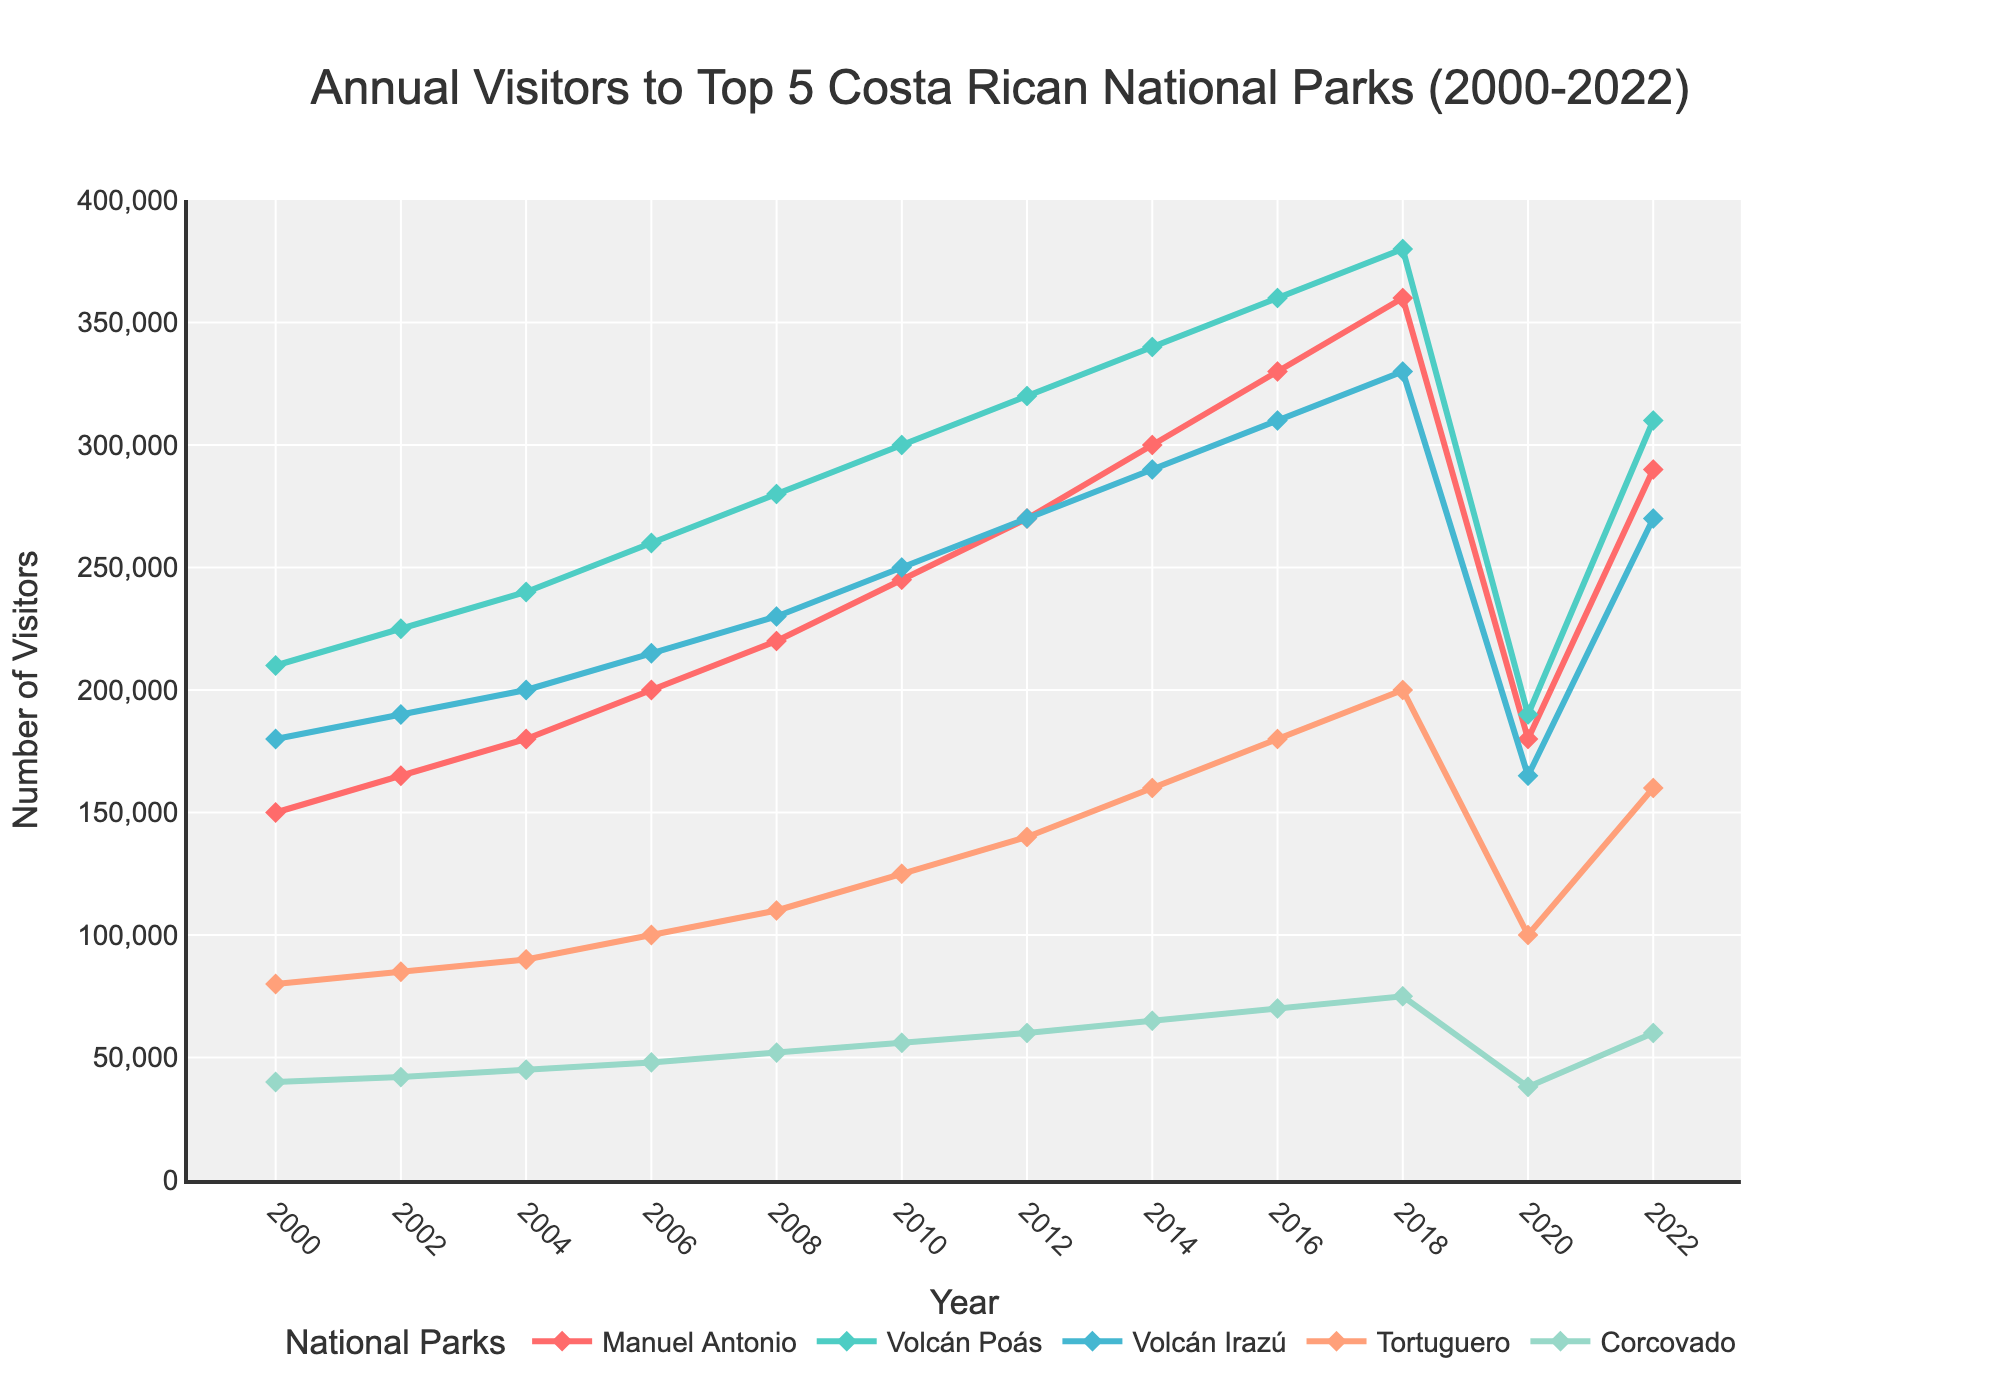What's the trend for visitor numbers to Manuel Antonio National Park from 2000 to 2022? Observe the line representing Manuel Antonio on the plot. The trend shows a steady increase from 150,000 visitors in 2000 to a peak of 360,000 in 2018, followed by a sharp drop in 2020, then a recovery to 290,000 in 2022.
Answer: Increasing until 2018, drop in 2020, partial recovery in 2022 Which national park had the highest number of visitors in 2020? Look for the highest point on the plot in the year 2020. Volcán Poás had the highest number of visitors with approximately 190,000.
Answer: Volcán Poás How did visitor numbers to Tortuguero National Park change between 2000 and 2022? Observe the plot line for Tortuguero. The visitor numbers increased from 80,000 in 2000 to 200,000 in 2018, then dropped to 100,000 in 2020, followed by a rise to 160,000 in 2022.
Answer: Increase until 2018, drop in 2020, rise in 2022 Which park had the most variable visitor numbers over the years? Compare the fluctuations in the lines for each park. Volcán Poás shows the highest amplitude of changes, reflecting higher variability.
Answer: Volcán Poás Which park had a greater number of visitors in 2010, Volcán Irazú or Corcovado? Examine the values on the plot for 2010. Volcán Irazú had 250,000 visitors while Corcovado had 56,000.
Answer: Volcán Irazú What is the difference in visitor numbers between Volcán Poás and Manuel Antonio in 2006? Look at the values for both parks in 2006. Volcán Poás had 260,000 visitors and Manuel Antonio had 200,000 visitors. The difference is 260,000 - 200,000 = 60,000.
Answer: 60,000 Is the rate of increase in visitor numbers steeper for Tortuguero or Corcovado from 2000 to 2008? Observe the slopes of the lines for Tortuguero and Corcovado from 2000 to 2008. Tortuguero's line (from 80,000 to 110,000) has a lesser increase compared to Corcovado's (from 40,000 to 52,000) when normalized for base values. Tortuguero's absolute increase is higher.
Answer: Tortuguero What's the average number of visitors for Volcán Poás across the years 2000, 2004, and 2008? Sum the visitor numbers for Volcán Poás in 2000 (210,000), 2004 (240,000), and 2008 (280,000), which gives 210,000 + 240,000 + 280,000 = 730,000. Divide by 3, the average is 730,000 / 3.
Answer: 243,333 Did any park show a decline in visitor numbers from 2018 to 2022? Compare the visitor numbers from 2018 to 2022 for each park. Manuel Antonio had a decrease from 360,000 to 290,000, indicating a decline.
Answer: Manuel Antonio What was the peak number of visitors for Volcán Poás between 2000 and 2022? Identify the highest point on the Volcán Poás line on the plot. The peak reached 380,000 visitors in 2018.
Answer: 380,000 